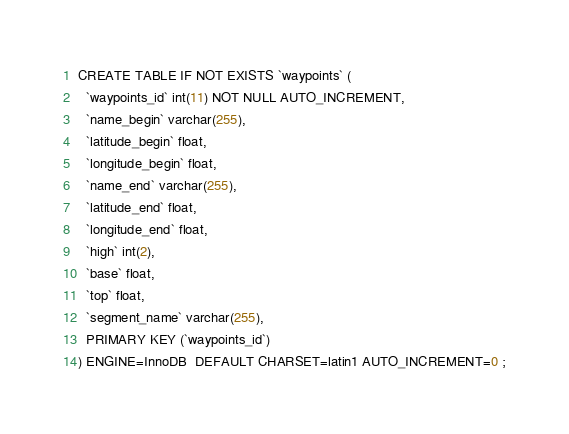Convert code to text. <code><loc_0><loc_0><loc_500><loc_500><_SQL_>CREATE TABLE IF NOT EXISTS `waypoints` (
  `waypoints_id` int(11) NOT NULL AUTO_INCREMENT,
  `name_begin` varchar(255),
  `latitude_begin` float,
  `longitude_begin` float,
  `name_end` varchar(255),
  `latitude_end` float,
  `longitude_end` float,
  `high` int(2),
  `base` float,
  `top` float,
  `segment_name` varchar(255),
  PRIMARY KEY (`waypoints_id`)
) ENGINE=InnoDB  DEFAULT CHARSET=latin1 AUTO_INCREMENT=0 ;
</code> 